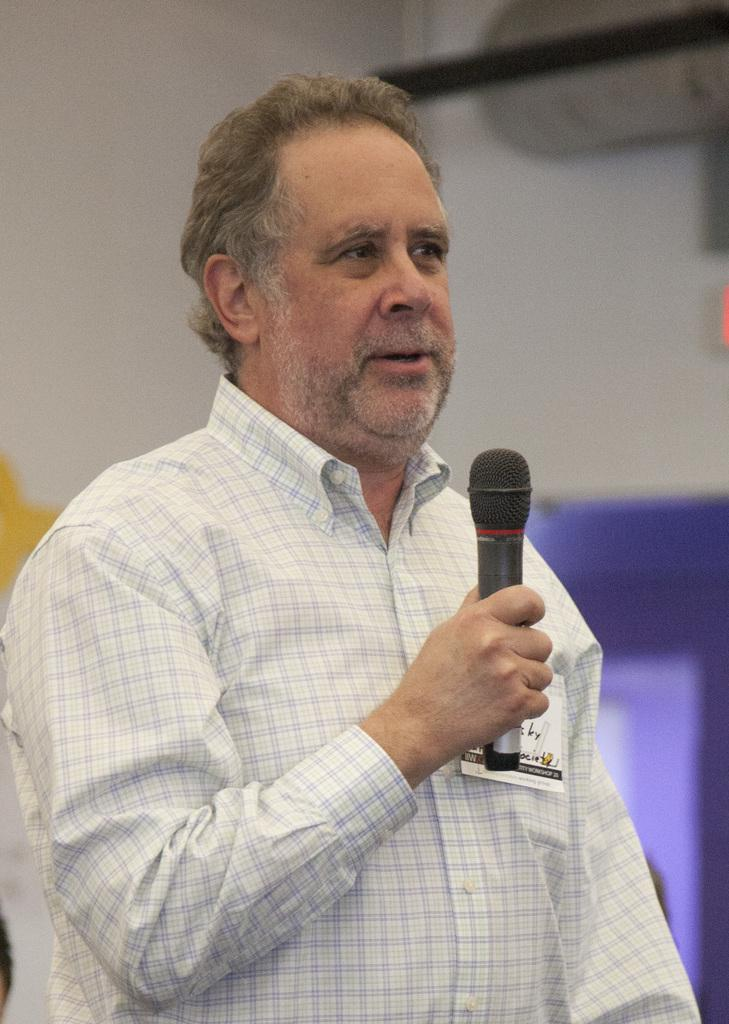Who is the main subject in the image? There is a man in the image. What is the man holding in the image? The man is holding a mic. What type of story is the man telling in the image? There is no story being told in the image; the man is simply holding a mic. What type of floor is visible in the image? There is no information about the floor in the image, as the focus is on the man and the mic. 